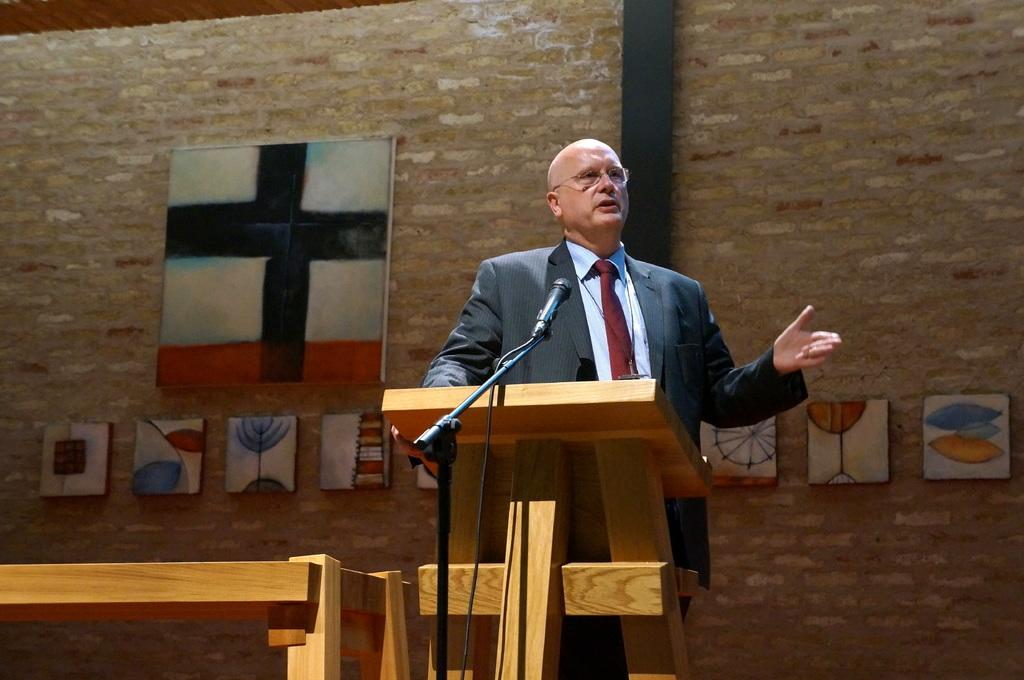Who is the main subject in the image? There is a man in the image. What is the man doing in the image? The man is standing in front of a desk. What can be seen in the center of the image? There is a mic in the center of the image. What is visible in the background of the image? There are portraits in the background of the image. What type of wood is used to make the holiday decorations in the image? There are no holiday decorations present in the image, so it is not possible to determine the type of wood used. 